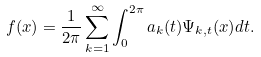Convert formula to latex. <formula><loc_0><loc_0><loc_500><loc_500>f ( x ) = \frac { 1 } { 2 \pi } \sum _ { k = 1 } ^ { \infty } \int _ { 0 } ^ { 2 \pi } a _ { k } ( t ) \Psi _ { k , t } ( x ) d t .</formula> 